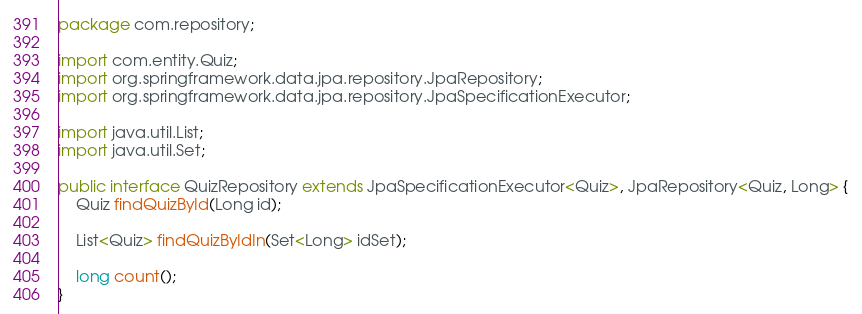Convert code to text. <code><loc_0><loc_0><loc_500><loc_500><_Java_>package com.repository;

import com.entity.Quiz;
import org.springframework.data.jpa.repository.JpaRepository;
import org.springframework.data.jpa.repository.JpaSpecificationExecutor;

import java.util.List;
import java.util.Set;

public interface QuizRepository extends JpaSpecificationExecutor<Quiz>, JpaRepository<Quiz, Long> {
    Quiz findQuizById(Long id);

    List<Quiz> findQuizByIdIn(Set<Long> idSet);

    long count();
}</code> 